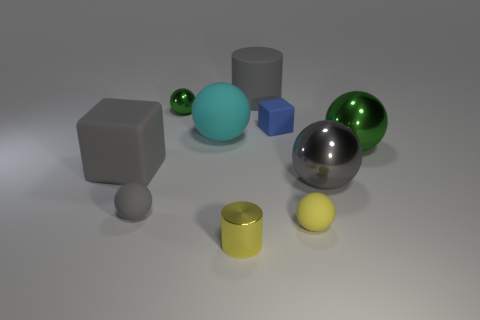Subtract all cyan spheres. How many spheres are left? 5 Subtract all big green shiny spheres. How many spheres are left? 5 Subtract all brown balls. Subtract all yellow cylinders. How many balls are left? 6 Subtract all cylinders. How many objects are left? 8 Add 5 small green shiny things. How many small green shiny things are left? 6 Add 1 small yellow matte spheres. How many small yellow matte spheres exist? 2 Subtract 1 gray cubes. How many objects are left? 9 Subtract all small yellow rubber spheres. Subtract all green things. How many objects are left? 7 